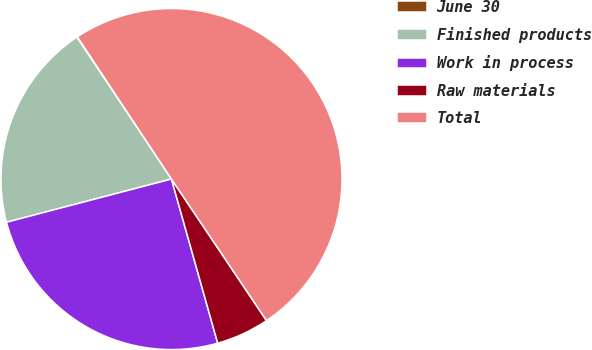<chart> <loc_0><loc_0><loc_500><loc_500><pie_chart><fcel>June 30<fcel>Finished products<fcel>Work in process<fcel>Raw materials<fcel>Total<nl><fcel>0.06%<fcel>19.71%<fcel>25.29%<fcel>5.04%<fcel>49.89%<nl></chart> 